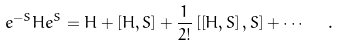Convert formula to latex. <formula><loc_0><loc_0><loc_500><loc_500>e ^ { - S } H e ^ { S } = H + \left [ H , S \right ] + \frac { 1 } { 2 ! } \left [ \left [ H , S \right ] , S \right ] + \cdots \ \ .</formula> 